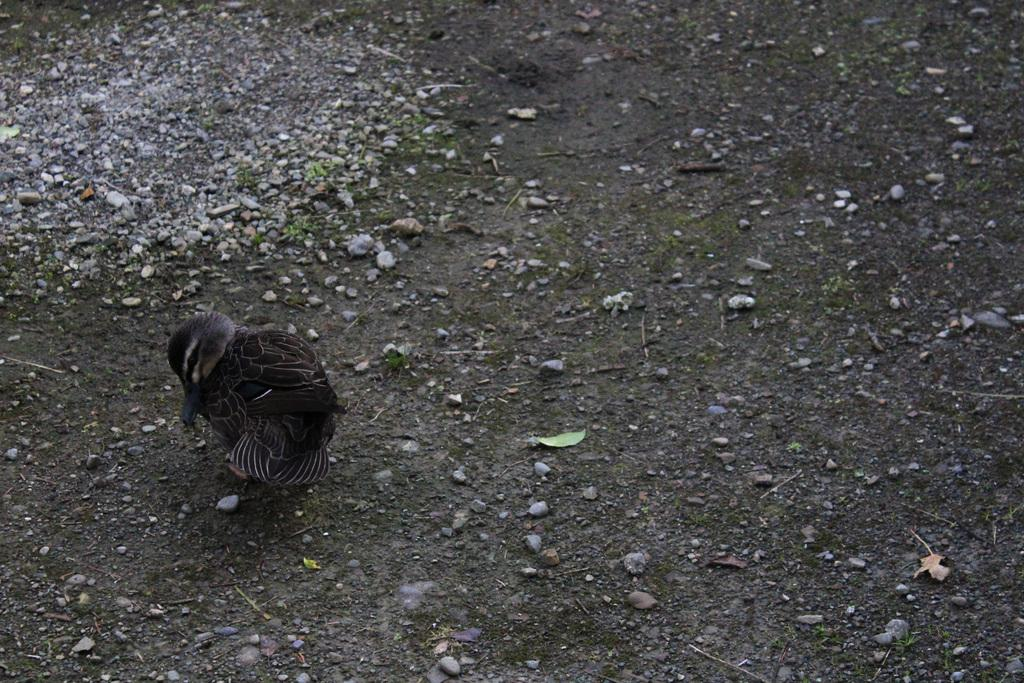What type of animal can be seen in the image? There is a bird in the image. Where is the bird located in the image? The bird is on the ground. What can be seen around the bird in the image? There are stones around the bird in the image. What type of nail is the bird using to build its nest in the image? There is no nail present in the image, nor is there any indication that the bird is building a nest. 